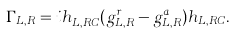Convert formula to latex. <formula><loc_0><loc_0><loc_500><loc_500>\Gamma _ { L , R } = i h ^ { \dag } _ { L , R C } ( g ^ { r } _ { L , R } - g ^ { a } _ { L , R } ) h _ { L , R C } .</formula> 